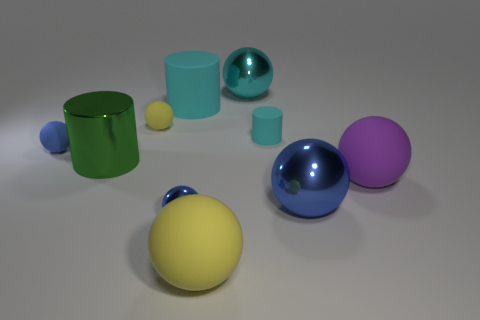Subtract all big cyan balls. How many balls are left? 6 Subtract all cyan balls. How many balls are left? 6 Subtract 2 cylinders. How many cylinders are left? 1 Subtract all gray cylinders. How many yellow balls are left? 2 Subtract all cylinders. How many objects are left? 7 Subtract all gray cylinders. Subtract all green blocks. How many cylinders are left? 3 Subtract all small cylinders. Subtract all large blue balls. How many objects are left? 8 Add 8 cyan spheres. How many cyan spheres are left? 9 Add 9 green cylinders. How many green cylinders exist? 10 Subtract 0 blue cylinders. How many objects are left? 10 